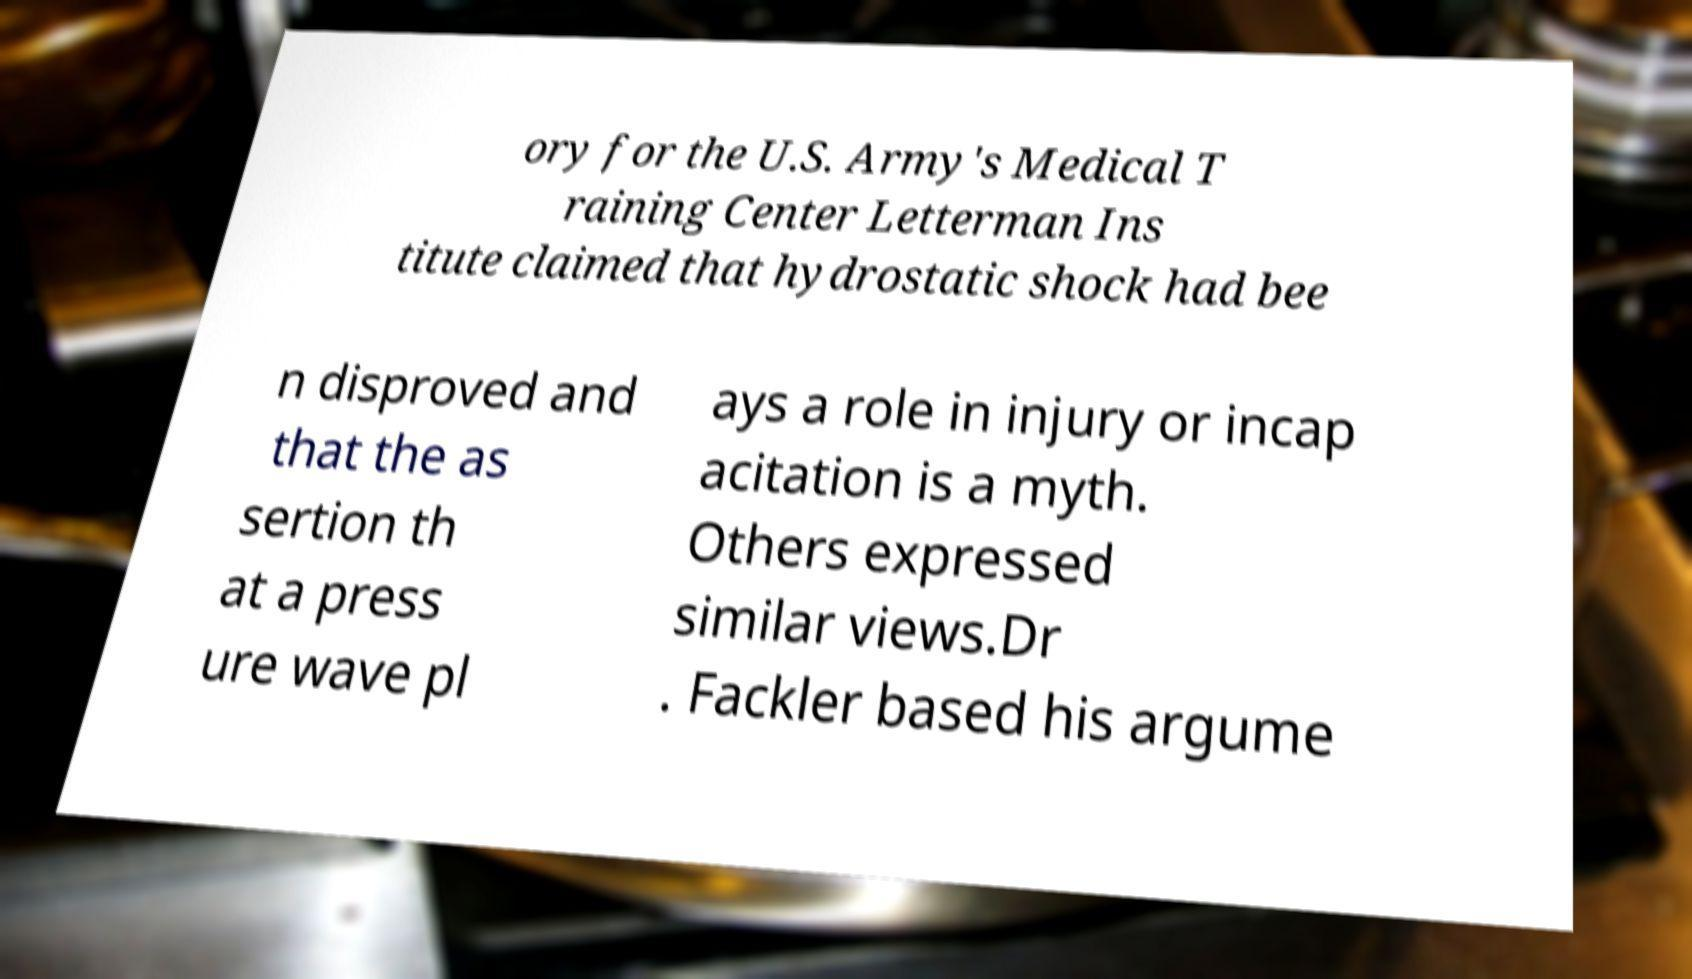Can you read and provide the text displayed in the image?This photo seems to have some interesting text. Can you extract and type it out for me? ory for the U.S. Army's Medical T raining Center Letterman Ins titute claimed that hydrostatic shock had bee n disproved and that the as sertion th at a press ure wave pl ays a role in injury or incap acitation is a myth. Others expressed similar views.Dr . Fackler based his argume 